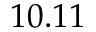Convert formula to latex. <formula><loc_0><loc_0><loc_500><loc_500>1 0 . 1 1</formula> 